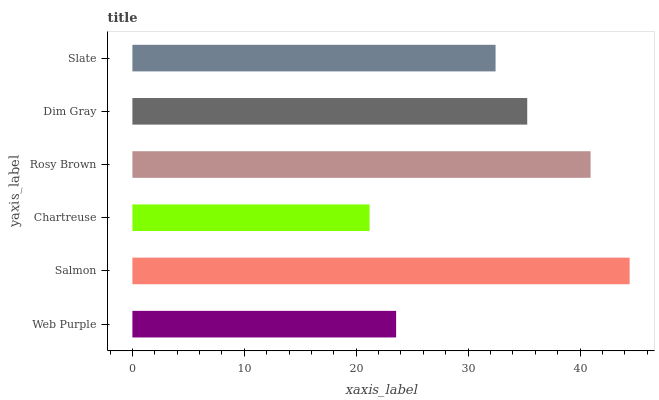Is Chartreuse the minimum?
Answer yes or no. Yes. Is Salmon the maximum?
Answer yes or no. Yes. Is Salmon the minimum?
Answer yes or no. No. Is Chartreuse the maximum?
Answer yes or no. No. Is Salmon greater than Chartreuse?
Answer yes or no. Yes. Is Chartreuse less than Salmon?
Answer yes or no. Yes. Is Chartreuse greater than Salmon?
Answer yes or no. No. Is Salmon less than Chartreuse?
Answer yes or no. No. Is Dim Gray the high median?
Answer yes or no. Yes. Is Slate the low median?
Answer yes or no. Yes. Is Chartreuse the high median?
Answer yes or no. No. Is Salmon the low median?
Answer yes or no. No. 